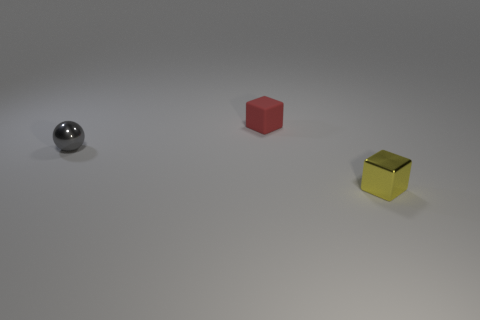Add 1 tiny yellow blocks. How many objects exist? 4 Subtract all balls. How many objects are left? 2 Add 3 large green matte balls. How many large green matte balls exist? 3 Subtract 1 gray balls. How many objects are left? 2 Subtract all blocks. Subtract all large gray matte spheres. How many objects are left? 1 Add 2 tiny red rubber things. How many tiny red rubber things are left? 3 